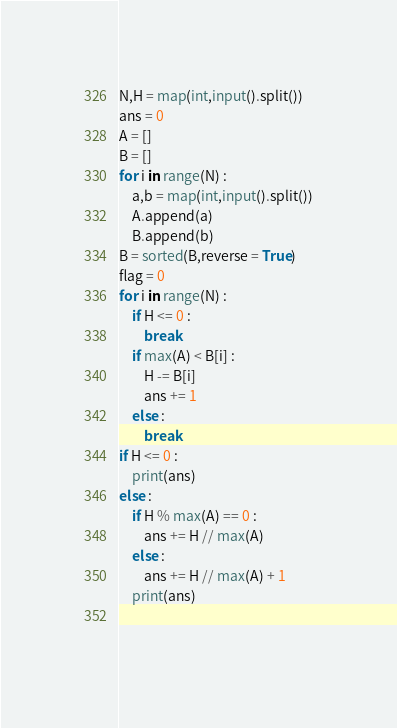Convert code to text. <code><loc_0><loc_0><loc_500><loc_500><_Python_>N,H = map(int,input().split())
ans = 0
A = []
B = []
for i in range(N) :
    a,b = map(int,input().split())
    A.append(a)
    B.append(b)
B = sorted(B,reverse = True)
flag = 0
for i in range(N) :
    if H <= 0 :
        break
    if max(A) < B[i] :
        H -= B[i]
        ans += 1
    else :
        break
if H <= 0 :
    print(ans)
else :
    if H % max(A) == 0 :
        ans += H // max(A)
    else :
        ans += H // max(A) + 1
    print(ans)
    
   </code> 